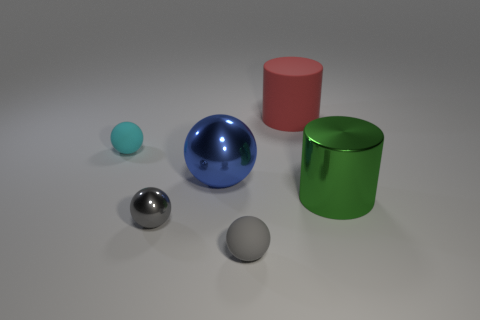There is another tiny thing that is the same color as the tiny metallic thing; what is it made of?
Keep it short and to the point. Rubber. What number of shiny things are either red cylinders or small brown balls?
Offer a terse response. 0. There is a big thing that is left of the red cylinder; is its shape the same as the large red matte thing behind the green metal cylinder?
Give a very brief answer. No. There is a green metal cylinder; what number of large green things are in front of it?
Give a very brief answer. 0. Are there any gray things made of the same material as the large sphere?
Offer a very short reply. Yes. There is a cyan object that is the same size as the gray metallic object; what is its material?
Your answer should be very brief. Rubber. Are the small cyan object and the red thing made of the same material?
Offer a very short reply. Yes. How many objects are either cyan matte balls or big red rubber things?
Your response must be concise. 2. What is the shape of the tiny matte thing in front of the tiny cyan matte sphere?
Give a very brief answer. Sphere. The other big thing that is made of the same material as the cyan object is what color?
Provide a succinct answer. Red. 